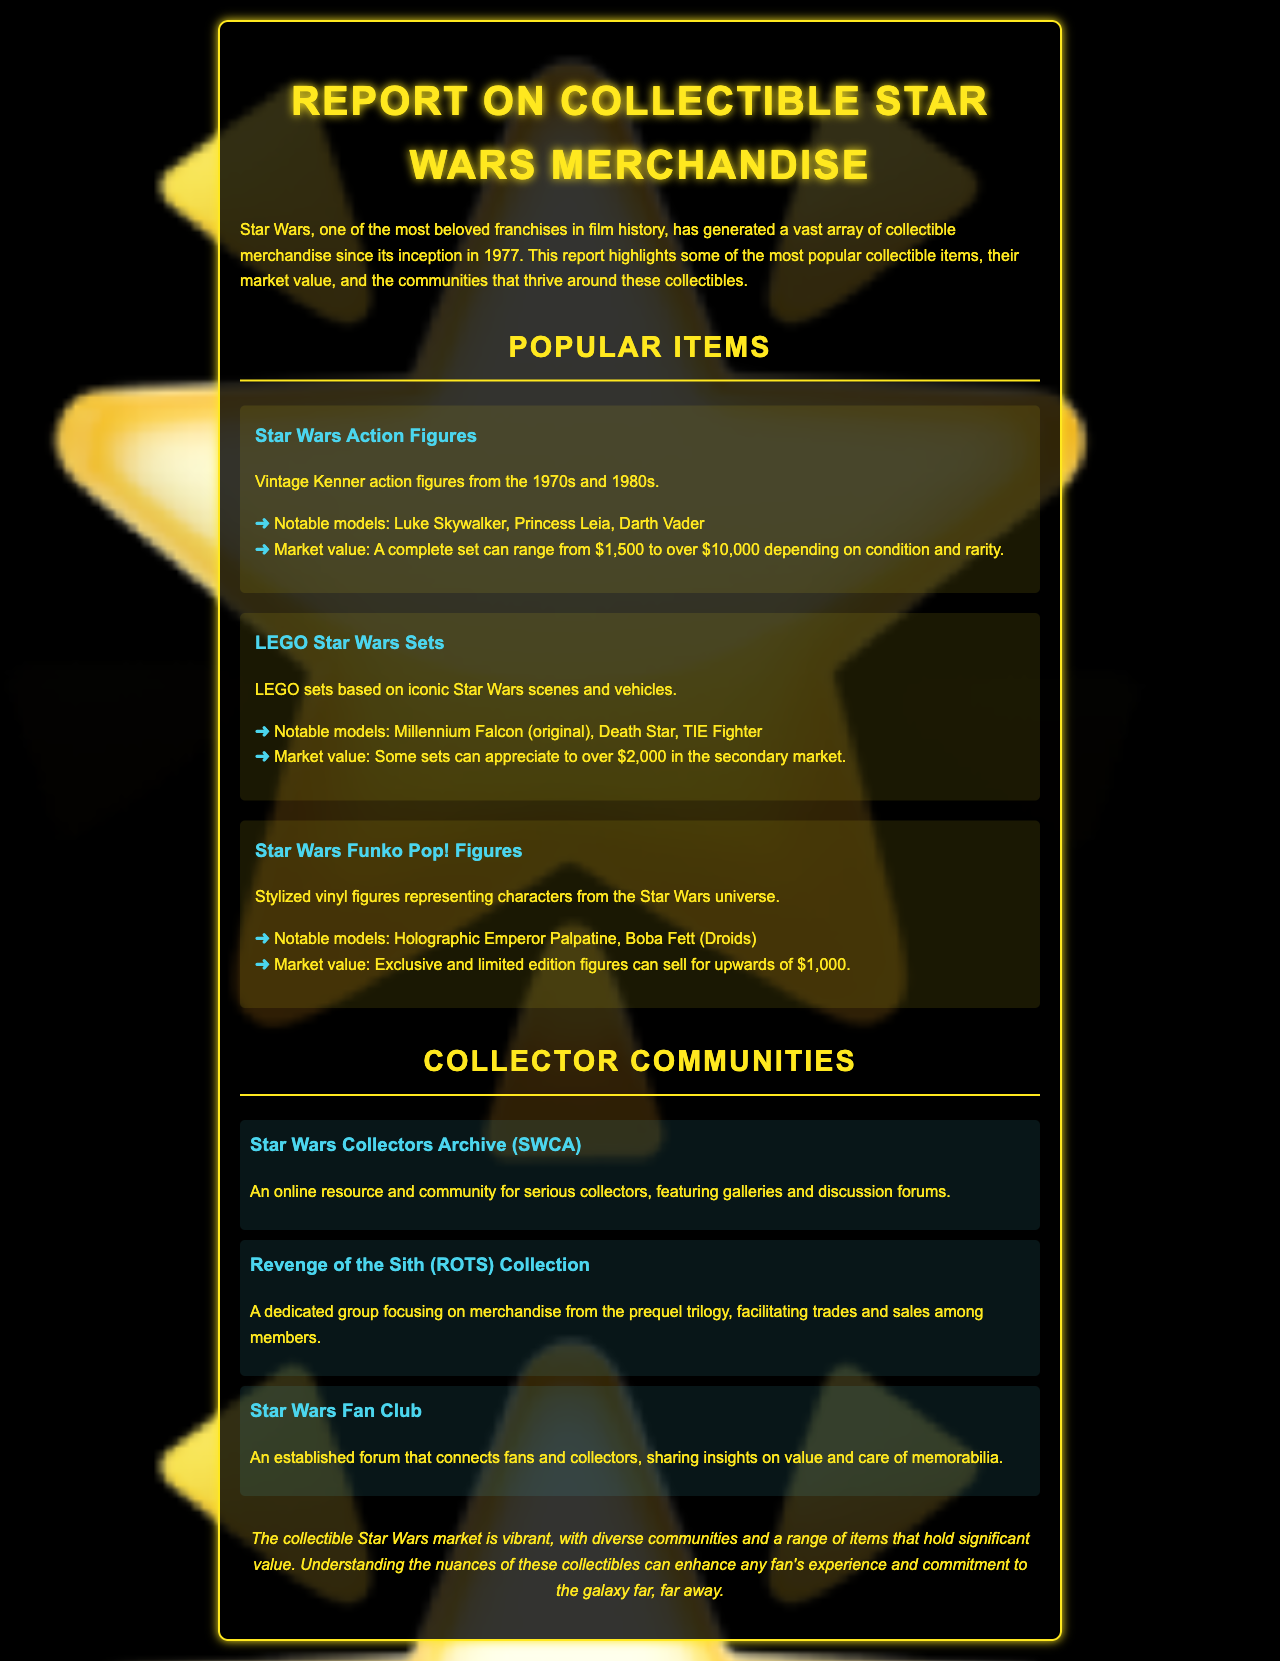What are vintage action figures? Vintage Kenner action figures from the 1970s and 1980s are considered collectible items, as noted in the report.
Answer: Vintage Kenner action figures What is the market value range for a complete set of Star Wars action figures? The report states that the market value for a complete set can range from $1,500 to over $10,000 depending on condition and rarity.
Answer: $1,500 to over $10,000 Which LEGO set can appreciate to over $2,000? According to the document, some LEGO Star Wars sets can appreciate to over $2,000 in the secondary market.
Answer: LEGO Star Wars sets What notable model is mentioned for Funko Pop! figures? The report highlights Holographic Emperor Palpatine as a notable model among Funko Pop! figures.
Answer: Holographic Emperor Palpatine What is the Star Wars Collectors Archive (SWCA)? SWCA is described as an online resource and community for serious collectors, featuring galleries and discussion forums.
Answer: An online resource and community Which community is focused on merchandise from the prequel trilogy? The document describes the Revenge of the Sith (ROTS) Collection as a group focused on merchandise from the prequel trilogy.
Answer: Revenge of the Sith (ROTS) Collection How many notable models are listed for Star Wars action figures? The report lists three notable models: Luke Skywalker, Princess Leia, and Darth Vader.
Answer: Three What is the aim of the Star Wars Fan Club? The document mentions that the Star Wars Fan Club connects fans and collectors, sharing insights on value and care of memorabilia.
Answer: Connects fans and collectors What is the overall theme of the report? The conclusion indicates that the collectible Star Wars market is vibrant and diverse, encompassing various items and communities.
Answer: Vibrant and diverse 